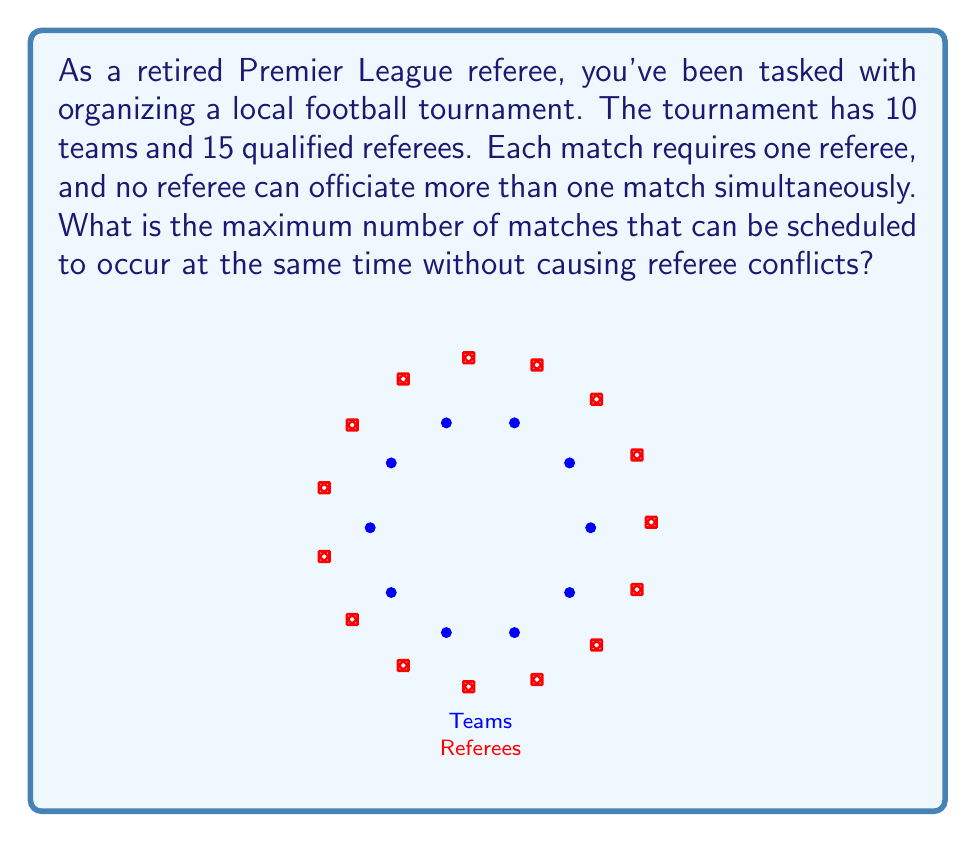Show me your answer to this math problem. To solve this problem, we need to consider the limiting factor in scheduling simultaneous matches. Let's approach this step-by-step:

1) Each match requires two teams and one referee.

2) The number of teams is not the limiting factor here. With 10 teams, we could theoretically have up to 5 simultaneous matches (as each match requires 2 teams).

3) The limiting factor is the number of available referees. We have 15 referees in total.

4) Since each match requires one referee, and no referee can officiate more than one match at a time, the maximum number of simultaneous matches is equal to the number of available referees.

5) Therefore, we can schedule a maximum of 15 matches simultaneously without causing referee conflicts.

6) We can represent this mathematically as:

   $$\text{Max Simultaneous Matches} = \min(\lfloor\frac{\text{Number of Teams}}{2}\rfloor, \text{Number of Referees})$$

   Where $\lfloor \rfloor$ represents the floor function (rounding down to the nearest integer).

7) In this case:
   $$\text{Max Simultaneous Matches} = \min(\lfloor\frac{10}{2}\rfloor, 15) = \min(5, 15) = 5$$

However, note that while we could theoretically schedule 15 simultaneous matches based on the number of referees, we are constrained by the number of teams. With 10 teams, we can only have a maximum of 5 matches occurring simultaneously.
Answer: 5 matches 